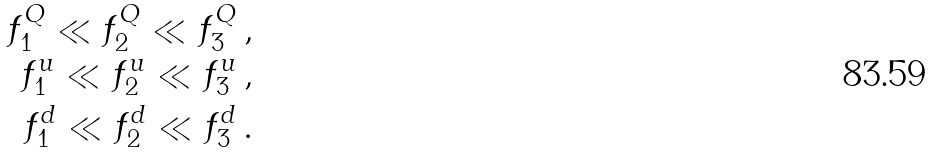Convert formula to latex. <formula><loc_0><loc_0><loc_500><loc_500>f ^ { Q } _ { 1 } \ll f ^ { Q } _ { 2 } \ll f ^ { Q } _ { 3 } \, , \\ f ^ { u } _ { 1 } \ll f ^ { u } _ { 2 } \ll f ^ { u } _ { 3 } \, , \\ f ^ { d } _ { 1 } \ll f ^ { d } _ { 2 } \ll f ^ { d } _ { 3 } \, .</formula> 